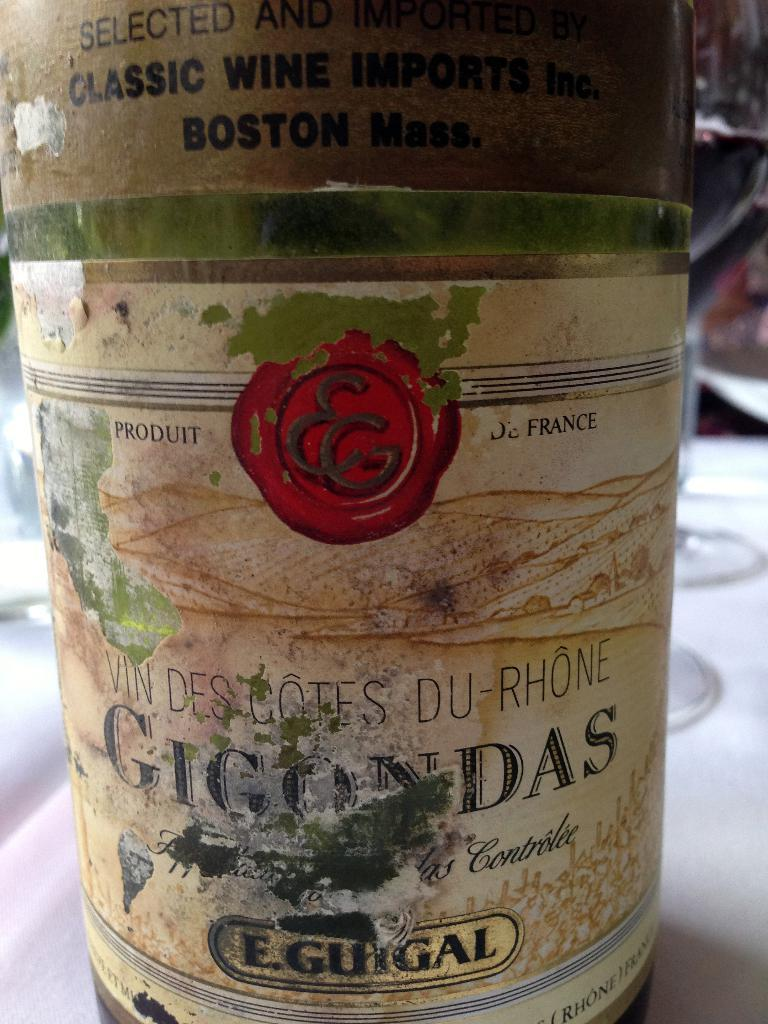<image>
Summarize the visual content of the image. the word eguigal is on the bottle of something 